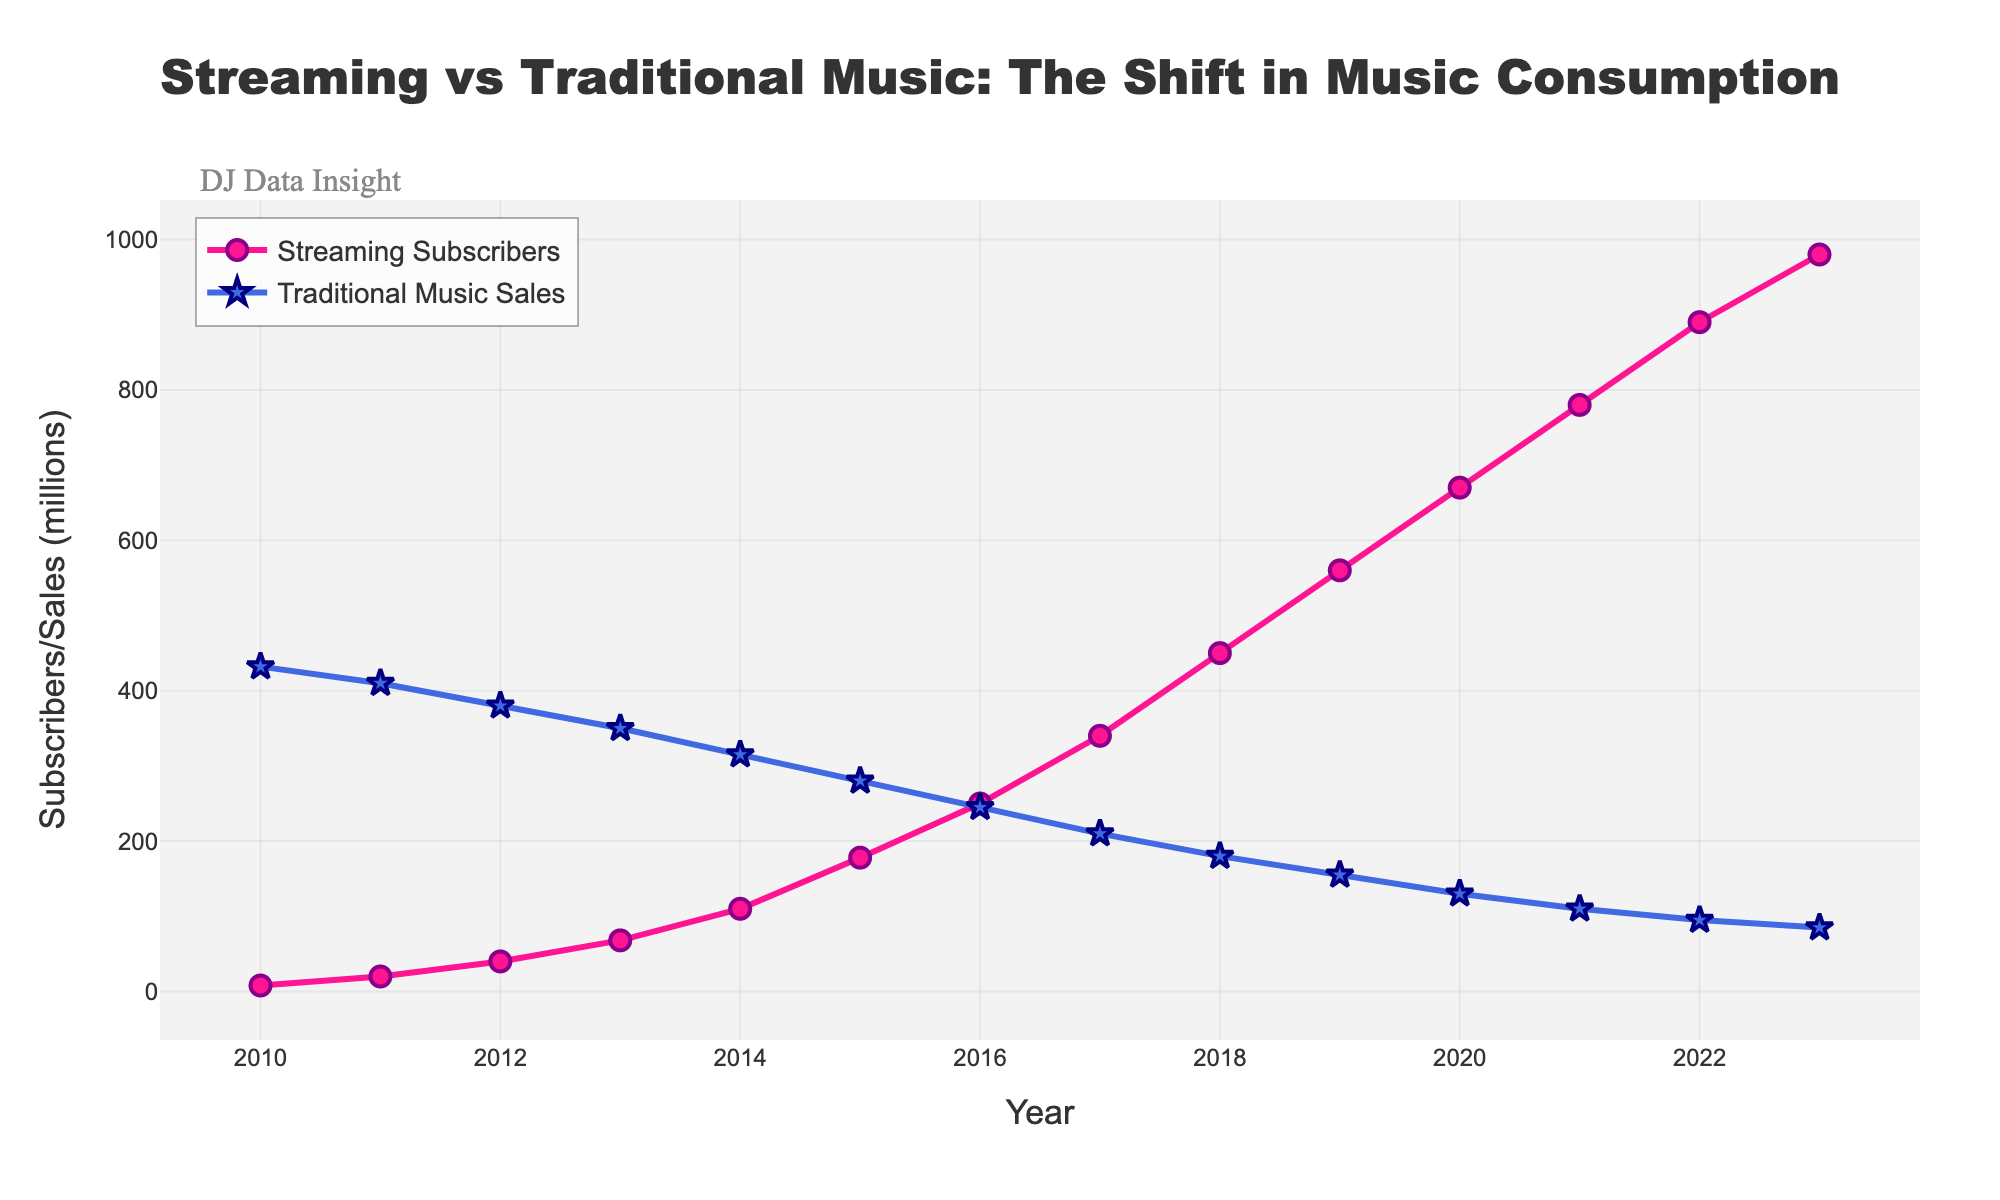How did the number of streaming subscribers change between 2010 and 2023? To find the change, subtract the number of streaming subscribers in 2010 from the number in 2023: 980 million (2023) - 8 million (2010) = 972 million
Answer: 972 million In what year did streaming subscribers first surpass traditional music sales? Check the trend lines for both streaming subscribers and traditional music sales. The two lines intersect between 2015 and 2016, indicating the surpassing year.
Answer: 2016 What is the difference in traditional music sales between 2010 and 2023? Subtract the value of traditional music sales in 2023 from the value in 2010: 432 million (2010) - 85 million (2023) = 347 million
Answer: 347 million How do streaming subscribers in 2019 compare to 2020? Compare the heights of the streaming subscribers markers for 2019 and 2020. In 2019, there are 560 million subscribers, and in 2020, there are 670 million, so there is an increase.
Answer: Increased by 110 million What color represents traditional music sales, and what shape are the markers? The traditional music sales are represented by the blue line with star-shaped markers.
Answer: Blue, star-shaped Calculate the average annual growth in streaming subscribers from 2010 to 2023. First, find the total growth: 980 - 8 = 972 million. Then, divide by the number of years: 972 million / (2023 - 2010) = 972 million / 13 ≈ 74.77 million per year
Answer: ≈ 74.77 million per year Which year saw the highest number of traditional music sales? Locate the peak point of the traditional music sales line. The highest value appears in 2010 with 432 million sales.
Answer: 2010 What is the rate of decline in traditional music sales between 2015 and 2023? Calculate the difference between 2015 and 2023: 280 million (2015) - 85 million (2023) = 195 million. Then, divide by the number of years: 195 million / (2023 - 2015) = 195 million / 8 ≈ 24.38 million per year
Answer: ≈ 24.38 million per year By how much did streaming subscribers increase between the years 2017 and 2022? Subtract the subscribers in 2017 from those in 2022: 890 million (2022) - 340 million (2017) = 550 million
Answer: 550 million What visual element indicates the highest point for traditional music sales? The highest point for traditional music sales is indicated by the tallest star marker on the line representing traditional music sales.
Answer: The tallest star marker 